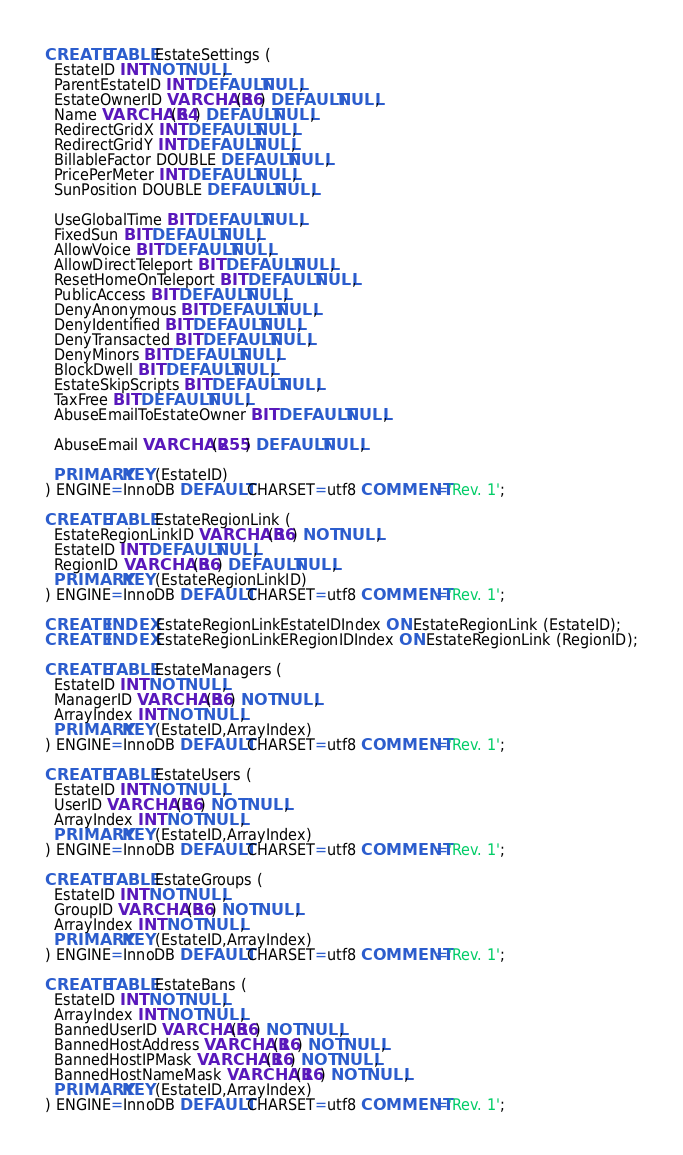Convert code to text. <code><loc_0><loc_0><loc_500><loc_500><_SQL_>CREATE TABLE EstateSettings (
  EstateID INT NOT NULL,
  ParentEstateID INT DEFAULT NULL,
  EstateOwnerID VARCHAR(36) DEFAULT NULL,
  Name VARCHAR(64) DEFAULT NULL,
  RedirectGridX INT DEFAULT NULL,
  RedirectGridY INT DEFAULT NULL,
  BillableFactor DOUBLE DEFAULT NULL,
  PricePerMeter INT DEFAULT NULL,
  SunPosition DOUBLE DEFAULT NULL,
  
  UseGlobalTime BIT DEFAULT NULL,
  FixedSun BIT DEFAULT NULL,
  AllowVoice BIT DEFAULT NULL,
  AllowDirectTeleport BIT DEFAULT NULL,
  ResetHomeOnTeleport BIT DEFAULT NULL,
  PublicAccess BIT DEFAULT NULL,
  DenyAnonymous BIT DEFAULT NULL,
  DenyIdentified BIT DEFAULT NULL,
  DenyTransacted BIT DEFAULT NULL,
  DenyMinors BIT DEFAULT NULL,
  BlockDwell BIT DEFAULT NULL,
  EstateSkipScripts BIT DEFAULT NULL,
  TaxFree BIT DEFAULT NULL,
  AbuseEmailToEstateOwner BIT DEFAULT NULL,
  
  AbuseEmail VARCHAR(255) DEFAULT NULL,

  PRIMARY KEY (EstateID)
) ENGINE=InnoDB DEFAULT CHARSET=utf8 COMMENT='Rev. 1';

CREATE TABLE EstateRegionLink (
  EstateRegionLinkID VARCHAR(36) NOT NULL,
  EstateID INT DEFAULT NULL,
  RegionID VARCHAR(36) DEFAULT NULL,
  PRIMARY KEY (EstateRegionLinkID)
) ENGINE=InnoDB DEFAULT CHARSET=utf8 COMMENT='Rev. 1';

CREATE INDEX EstateRegionLinkEstateIDIndex ON EstateRegionLink (EstateID);
CREATE INDEX EstateRegionLinkERegionIDIndex ON EstateRegionLink (RegionID);

CREATE TABLE EstateManagers (
  EstateID INT NOT NULL,
  ManagerID VARCHAR(36) NOT NULL,
  ArrayIndex INT NOT NULL,
  PRIMARY KEY (EstateID,ArrayIndex)
) ENGINE=InnoDB DEFAULT CHARSET=utf8 COMMENT='Rev. 1';

CREATE TABLE EstateUsers (
  EstateID INT NOT NULL,
  UserID VARCHAR(36) NOT NULL,
  ArrayIndex INT NOT NULL,
  PRIMARY KEY (EstateID,ArrayIndex)
) ENGINE=InnoDB DEFAULT CHARSET=utf8 COMMENT='Rev. 1';

CREATE TABLE EstateGroups (
  EstateID INT NOT NULL,
  GroupID VARCHAR(36) NOT NULL,
  ArrayIndex INT NOT NULL,
  PRIMARY KEY (EstateID,ArrayIndex)
) ENGINE=InnoDB DEFAULT CHARSET=utf8 COMMENT='Rev. 1';

CREATE TABLE EstateBans (
  EstateID INT NOT NULL,
  ArrayIndex INT NOT NULL,
  BannedUserID VARCHAR(36) NOT NULL,
  BannedHostAddress VARCHAR(16) NOT NULL,
  BannedHostIPMask VARCHAR(16) NOT NULL,
  BannedHostNameMask VARCHAR(16) NOT NULL,
  PRIMARY KEY (EstateID,ArrayIndex)
) ENGINE=InnoDB DEFAULT CHARSET=utf8 COMMENT='Rev. 1';
</code> 